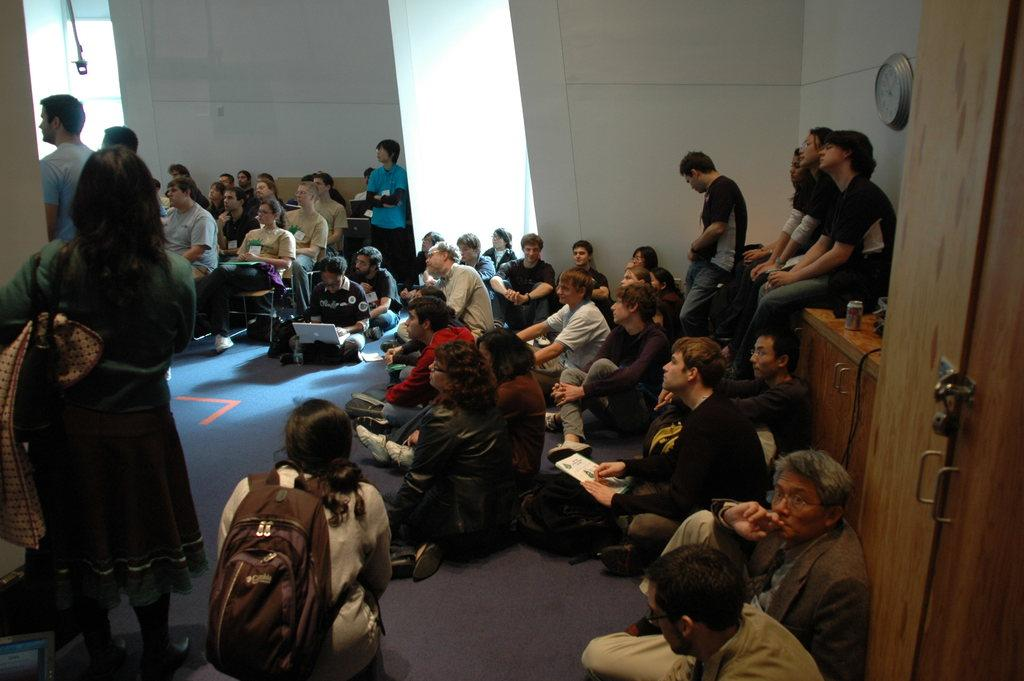What are the people in the image doing? The people in the image are operating laptops. How are the people positioned in the image? Some people are sitting on the floor, while others are sitting on tables. What type of cheese is being served to the family in the image? There is no cheese or family present in the image; it features people operating laptops. 